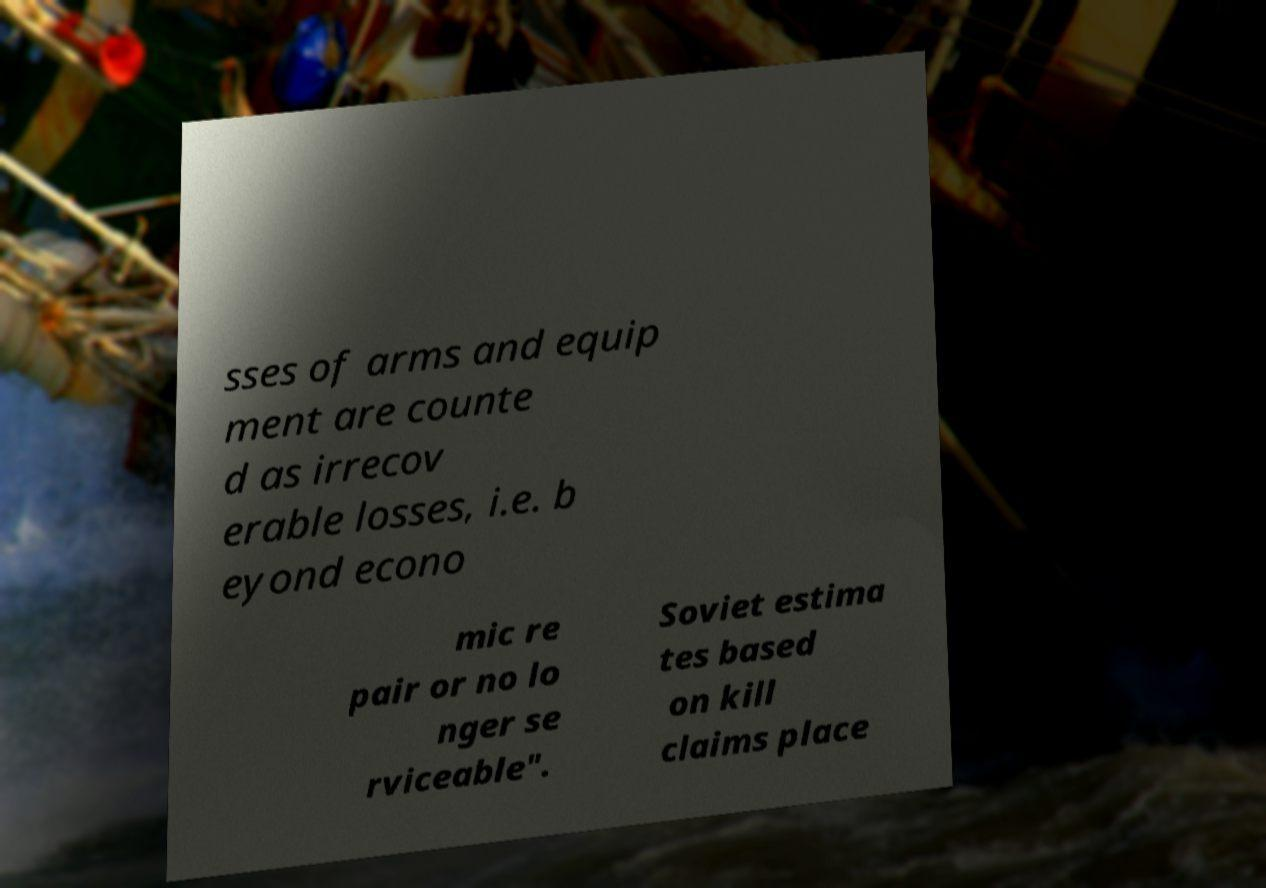There's text embedded in this image that I need extracted. Can you transcribe it verbatim? sses of arms and equip ment are counte d as irrecov erable losses, i.e. b eyond econo mic re pair or no lo nger se rviceable". Soviet estima tes based on kill claims place 